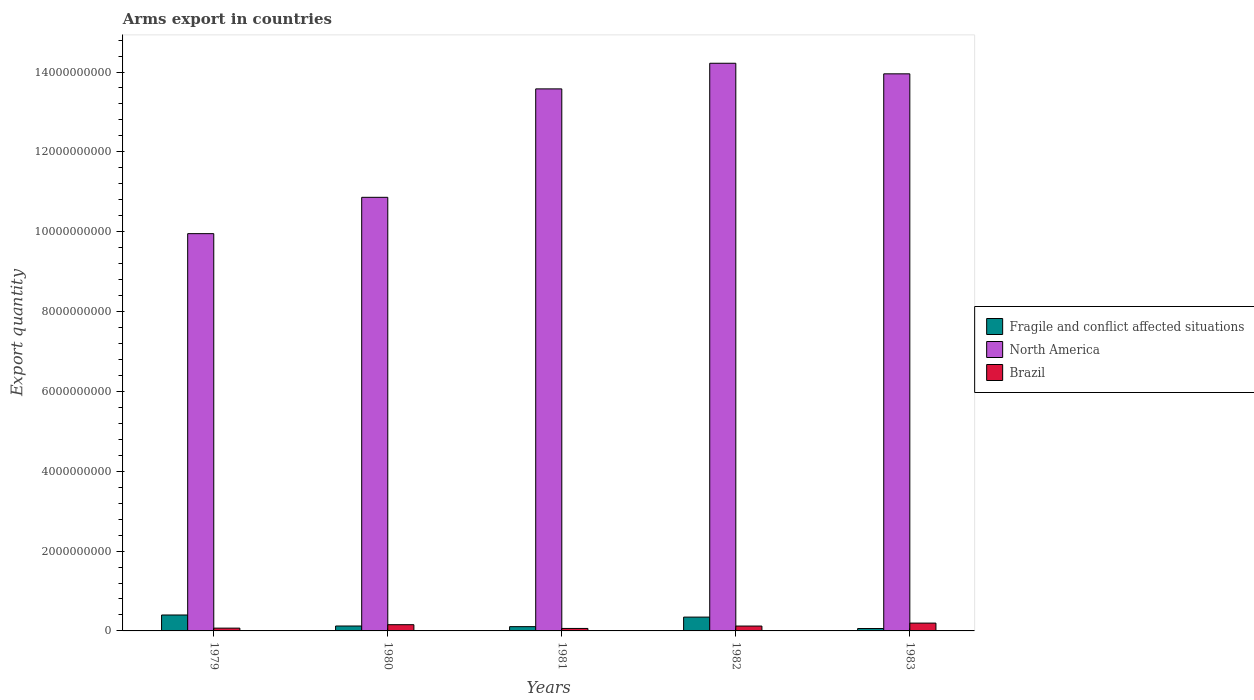How many different coloured bars are there?
Give a very brief answer. 3. How many bars are there on the 2nd tick from the left?
Ensure brevity in your answer.  3. How many bars are there on the 4th tick from the right?
Keep it short and to the point. 3. What is the label of the 4th group of bars from the left?
Keep it short and to the point. 1982. In how many cases, is the number of bars for a given year not equal to the number of legend labels?
Provide a short and direct response. 0. What is the total arms export in Brazil in 1979?
Your answer should be very brief. 7.00e+07. Across all years, what is the maximum total arms export in Brazil?
Offer a terse response. 1.96e+08. Across all years, what is the minimum total arms export in Brazil?
Your answer should be very brief. 6.20e+07. What is the total total arms export in North America in the graph?
Keep it short and to the point. 6.26e+1. What is the difference between the total arms export in North America in 1979 and that in 1982?
Provide a succinct answer. -4.27e+09. What is the difference between the total arms export in North America in 1981 and the total arms export in Fragile and conflict affected situations in 1983?
Ensure brevity in your answer.  1.35e+1. What is the average total arms export in Fragile and conflict affected situations per year?
Provide a succinct answer. 2.07e+08. In the year 1983, what is the difference between the total arms export in North America and total arms export in Brazil?
Offer a terse response. 1.38e+1. What is the ratio of the total arms export in Fragile and conflict affected situations in 1981 to that in 1983?
Your answer should be compact. 1.78. Is the difference between the total arms export in North America in 1980 and 1983 greater than the difference between the total arms export in Brazil in 1980 and 1983?
Provide a succinct answer. No. What is the difference between the highest and the second highest total arms export in Brazil?
Ensure brevity in your answer.  4.00e+07. What is the difference between the highest and the lowest total arms export in Fragile and conflict affected situations?
Provide a short and direct response. 3.39e+08. In how many years, is the total arms export in North America greater than the average total arms export in North America taken over all years?
Keep it short and to the point. 3. What does the 1st bar from the right in 1979 represents?
Your response must be concise. Brazil. Is it the case that in every year, the sum of the total arms export in North America and total arms export in Brazil is greater than the total arms export in Fragile and conflict affected situations?
Give a very brief answer. Yes. What is the difference between two consecutive major ticks on the Y-axis?
Give a very brief answer. 2.00e+09. Does the graph contain grids?
Give a very brief answer. No. Where does the legend appear in the graph?
Provide a short and direct response. Center right. How are the legend labels stacked?
Offer a very short reply. Vertical. What is the title of the graph?
Offer a very short reply. Arms export in countries. What is the label or title of the Y-axis?
Provide a succinct answer. Export quantity. What is the Export quantity of Fragile and conflict affected situations in 1979?
Ensure brevity in your answer.  3.99e+08. What is the Export quantity in North America in 1979?
Provide a short and direct response. 9.95e+09. What is the Export quantity in Brazil in 1979?
Your response must be concise. 7.00e+07. What is the Export quantity of Fragile and conflict affected situations in 1980?
Your answer should be compact. 1.23e+08. What is the Export quantity of North America in 1980?
Your response must be concise. 1.09e+1. What is the Export quantity in Brazil in 1980?
Your answer should be very brief. 1.56e+08. What is the Export quantity of Fragile and conflict affected situations in 1981?
Offer a terse response. 1.07e+08. What is the Export quantity of North America in 1981?
Your response must be concise. 1.36e+1. What is the Export quantity of Brazil in 1981?
Keep it short and to the point. 6.20e+07. What is the Export quantity of Fragile and conflict affected situations in 1982?
Your answer should be compact. 3.46e+08. What is the Export quantity of North America in 1982?
Provide a short and direct response. 1.42e+1. What is the Export quantity of Brazil in 1982?
Provide a short and direct response. 1.22e+08. What is the Export quantity in Fragile and conflict affected situations in 1983?
Provide a short and direct response. 6.00e+07. What is the Export quantity in North America in 1983?
Offer a very short reply. 1.40e+1. What is the Export quantity in Brazil in 1983?
Provide a succinct answer. 1.96e+08. Across all years, what is the maximum Export quantity in Fragile and conflict affected situations?
Provide a succinct answer. 3.99e+08. Across all years, what is the maximum Export quantity of North America?
Provide a short and direct response. 1.42e+1. Across all years, what is the maximum Export quantity of Brazil?
Your answer should be compact. 1.96e+08. Across all years, what is the minimum Export quantity of Fragile and conflict affected situations?
Keep it short and to the point. 6.00e+07. Across all years, what is the minimum Export quantity in North America?
Offer a terse response. 9.95e+09. Across all years, what is the minimum Export quantity in Brazil?
Provide a short and direct response. 6.20e+07. What is the total Export quantity in Fragile and conflict affected situations in the graph?
Provide a succinct answer. 1.04e+09. What is the total Export quantity of North America in the graph?
Keep it short and to the point. 6.26e+1. What is the total Export quantity in Brazil in the graph?
Give a very brief answer. 6.06e+08. What is the difference between the Export quantity in Fragile and conflict affected situations in 1979 and that in 1980?
Your response must be concise. 2.76e+08. What is the difference between the Export quantity of North America in 1979 and that in 1980?
Give a very brief answer. -9.10e+08. What is the difference between the Export quantity of Brazil in 1979 and that in 1980?
Offer a very short reply. -8.60e+07. What is the difference between the Export quantity of Fragile and conflict affected situations in 1979 and that in 1981?
Give a very brief answer. 2.92e+08. What is the difference between the Export quantity of North America in 1979 and that in 1981?
Offer a terse response. -3.63e+09. What is the difference between the Export quantity in Fragile and conflict affected situations in 1979 and that in 1982?
Offer a very short reply. 5.30e+07. What is the difference between the Export quantity of North America in 1979 and that in 1982?
Provide a succinct answer. -4.27e+09. What is the difference between the Export quantity of Brazil in 1979 and that in 1982?
Ensure brevity in your answer.  -5.20e+07. What is the difference between the Export quantity of Fragile and conflict affected situations in 1979 and that in 1983?
Your answer should be very brief. 3.39e+08. What is the difference between the Export quantity in North America in 1979 and that in 1983?
Offer a terse response. -4.00e+09. What is the difference between the Export quantity in Brazil in 1979 and that in 1983?
Offer a very short reply. -1.26e+08. What is the difference between the Export quantity in Fragile and conflict affected situations in 1980 and that in 1981?
Offer a very short reply. 1.60e+07. What is the difference between the Export quantity in North America in 1980 and that in 1981?
Provide a short and direct response. -2.72e+09. What is the difference between the Export quantity in Brazil in 1980 and that in 1981?
Your answer should be very brief. 9.40e+07. What is the difference between the Export quantity of Fragile and conflict affected situations in 1980 and that in 1982?
Ensure brevity in your answer.  -2.23e+08. What is the difference between the Export quantity in North America in 1980 and that in 1982?
Give a very brief answer. -3.36e+09. What is the difference between the Export quantity of Brazil in 1980 and that in 1982?
Offer a terse response. 3.40e+07. What is the difference between the Export quantity in Fragile and conflict affected situations in 1980 and that in 1983?
Offer a very short reply. 6.30e+07. What is the difference between the Export quantity of North America in 1980 and that in 1983?
Make the answer very short. -3.09e+09. What is the difference between the Export quantity of Brazil in 1980 and that in 1983?
Provide a succinct answer. -4.00e+07. What is the difference between the Export quantity of Fragile and conflict affected situations in 1981 and that in 1982?
Keep it short and to the point. -2.39e+08. What is the difference between the Export quantity of North America in 1981 and that in 1982?
Keep it short and to the point. -6.42e+08. What is the difference between the Export quantity in Brazil in 1981 and that in 1982?
Offer a terse response. -6.00e+07. What is the difference between the Export quantity of Fragile and conflict affected situations in 1981 and that in 1983?
Ensure brevity in your answer.  4.70e+07. What is the difference between the Export quantity in North America in 1981 and that in 1983?
Your answer should be very brief. -3.77e+08. What is the difference between the Export quantity of Brazil in 1981 and that in 1983?
Your answer should be very brief. -1.34e+08. What is the difference between the Export quantity of Fragile and conflict affected situations in 1982 and that in 1983?
Your answer should be very brief. 2.86e+08. What is the difference between the Export quantity in North America in 1982 and that in 1983?
Ensure brevity in your answer.  2.65e+08. What is the difference between the Export quantity in Brazil in 1982 and that in 1983?
Provide a short and direct response. -7.40e+07. What is the difference between the Export quantity of Fragile and conflict affected situations in 1979 and the Export quantity of North America in 1980?
Offer a terse response. -1.05e+1. What is the difference between the Export quantity of Fragile and conflict affected situations in 1979 and the Export quantity of Brazil in 1980?
Keep it short and to the point. 2.43e+08. What is the difference between the Export quantity of North America in 1979 and the Export quantity of Brazil in 1980?
Give a very brief answer. 9.80e+09. What is the difference between the Export quantity of Fragile and conflict affected situations in 1979 and the Export quantity of North America in 1981?
Your answer should be very brief. -1.32e+1. What is the difference between the Export quantity in Fragile and conflict affected situations in 1979 and the Export quantity in Brazil in 1981?
Keep it short and to the point. 3.37e+08. What is the difference between the Export quantity of North America in 1979 and the Export quantity of Brazil in 1981?
Provide a short and direct response. 9.89e+09. What is the difference between the Export quantity in Fragile and conflict affected situations in 1979 and the Export quantity in North America in 1982?
Offer a terse response. -1.38e+1. What is the difference between the Export quantity in Fragile and conflict affected situations in 1979 and the Export quantity in Brazil in 1982?
Keep it short and to the point. 2.77e+08. What is the difference between the Export quantity of North America in 1979 and the Export quantity of Brazil in 1982?
Ensure brevity in your answer.  9.83e+09. What is the difference between the Export quantity of Fragile and conflict affected situations in 1979 and the Export quantity of North America in 1983?
Your answer should be very brief. -1.36e+1. What is the difference between the Export quantity of Fragile and conflict affected situations in 1979 and the Export quantity of Brazil in 1983?
Your response must be concise. 2.03e+08. What is the difference between the Export quantity in North America in 1979 and the Export quantity in Brazil in 1983?
Make the answer very short. 9.76e+09. What is the difference between the Export quantity of Fragile and conflict affected situations in 1980 and the Export quantity of North America in 1981?
Your answer should be very brief. -1.35e+1. What is the difference between the Export quantity in Fragile and conflict affected situations in 1980 and the Export quantity in Brazil in 1981?
Provide a succinct answer. 6.10e+07. What is the difference between the Export quantity in North America in 1980 and the Export quantity in Brazil in 1981?
Ensure brevity in your answer.  1.08e+1. What is the difference between the Export quantity in Fragile and conflict affected situations in 1980 and the Export quantity in North America in 1982?
Your answer should be compact. -1.41e+1. What is the difference between the Export quantity in Fragile and conflict affected situations in 1980 and the Export quantity in Brazil in 1982?
Your answer should be very brief. 1.00e+06. What is the difference between the Export quantity in North America in 1980 and the Export quantity in Brazil in 1982?
Give a very brief answer. 1.07e+1. What is the difference between the Export quantity in Fragile and conflict affected situations in 1980 and the Export quantity in North America in 1983?
Provide a succinct answer. -1.38e+1. What is the difference between the Export quantity in Fragile and conflict affected situations in 1980 and the Export quantity in Brazil in 1983?
Ensure brevity in your answer.  -7.30e+07. What is the difference between the Export quantity of North America in 1980 and the Export quantity of Brazil in 1983?
Give a very brief answer. 1.07e+1. What is the difference between the Export quantity in Fragile and conflict affected situations in 1981 and the Export quantity in North America in 1982?
Offer a very short reply. -1.41e+1. What is the difference between the Export quantity in Fragile and conflict affected situations in 1981 and the Export quantity in Brazil in 1982?
Give a very brief answer. -1.50e+07. What is the difference between the Export quantity in North America in 1981 and the Export quantity in Brazil in 1982?
Provide a short and direct response. 1.35e+1. What is the difference between the Export quantity in Fragile and conflict affected situations in 1981 and the Export quantity in North America in 1983?
Make the answer very short. -1.38e+1. What is the difference between the Export quantity of Fragile and conflict affected situations in 1981 and the Export quantity of Brazil in 1983?
Your answer should be compact. -8.90e+07. What is the difference between the Export quantity of North America in 1981 and the Export quantity of Brazil in 1983?
Provide a short and direct response. 1.34e+1. What is the difference between the Export quantity of Fragile and conflict affected situations in 1982 and the Export quantity of North America in 1983?
Keep it short and to the point. -1.36e+1. What is the difference between the Export quantity of Fragile and conflict affected situations in 1982 and the Export quantity of Brazil in 1983?
Ensure brevity in your answer.  1.50e+08. What is the difference between the Export quantity of North America in 1982 and the Export quantity of Brazil in 1983?
Make the answer very short. 1.40e+1. What is the average Export quantity in Fragile and conflict affected situations per year?
Offer a terse response. 2.07e+08. What is the average Export quantity in North America per year?
Your answer should be very brief. 1.25e+1. What is the average Export quantity of Brazil per year?
Provide a short and direct response. 1.21e+08. In the year 1979, what is the difference between the Export quantity of Fragile and conflict affected situations and Export quantity of North America?
Keep it short and to the point. -9.55e+09. In the year 1979, what is the difference between the Export quantity of Fragile and conflict affected situations and Export quantity of Brazil?
Provide a short and direct response. 3.29e+08. In the year 1979, what is the difference between the Export quantity of North America and Export quantity of Brazil?
Provide a short and direct response. 9.88e+09. In the year 1980, what is the difference between the Export quantity in Fragile and conflict affected situations and Export quantity in North America?
Provide a short and direct response. -1.07e+1. In the year 1980, what is the difference between the Export quantity of Fragile and conflict affected situations and Export quantity of Brazil?
Give a very brief answer. -3.30e+07. In the year 1980, what is the difference between the Export quantity of North America and Export quantity of Brazil?
Your answer should be very brief. 1.07e+1. In the year 1981, what is the difference between the Export quantity in Fragile and conflict affected situations and Export quantity in North America?
Offer a very short reply. -1.35e+1. In the year 1981, what is the difference between the Export quantity of Fragile and conflict affected situations and Export quantity of Brazil?
Make the answer very short. 4.50e+07. In the year 1981, what is the difference between the Export quantity in North America and Export quantity in Brazil?
Make the answer very short. 1.35e+1. In the year 1982, what is the difference between the Export quantity of Fragile and conflict affected situations and Export quantity of North America?
Keep it short and to the point. -1.39e+1. In the year 1982, what is the difference between the Export quantity of Fragile and conflict affected situations and Export quantity of Brazil?
Offer a terse response. 2.24e+08. In the year 1982, what is the difference between the Export quantity in North America and Export quantity in Brazil?
Your answer should be very brief. 1.41e+1. In the year 1983, what is the difference between the Export quantity of Fragile and conflict affected situations and Export quantity of North America?
Your response must be concise. -1.39e+1. In the year 1983, what is the difference between the Export quantity of Fragile and conflict affected situations and Export quantity of Brazil?
Offer a very short reply. -1.36e+08. In the year 1983, what is the difference between the Export quantity in North America and Export quantity in Brazil?
Make the answer very short. 1.38e+1. What is the ratio of the Export quantity in Fragile and conflict affected situations in 1979 to that in 1980?
Provide a short and direct response. 3.24. What is the ratio of the Export quantity of North America in 1979 to that in 1980?
Provide a short and direct response. 0.92. What is the ratio of the Export quantity in Brazil in 1979 to that in 1980?
Your answer should be very brief. 0.45. What is the ratio of the Export quantity of Fragile and conflict affected situations in 1979 to that in 1981?
Your response must be concise. 3.73. What is the ratio of the Export quantity in North America in 1979 to that in 1981?
Provide a short and direct response. 0.73. What is the ratio of the Export quantity of Brazil in 1979 to that in 1981?
Your answer should be very brief. 1.13. What is the ratio of the Export quantity in Fragile and conflict affected situations in 1979 to that in 1982?
Offer a terse response. 1.15. What is the ratio of the Export quantity in North America in 1979 to that in 1982?
Make the answer very short. 0.7. What is the ratio of the Export quantity of Brazil in 1979 to that in 1982?
Your answer should be very brief. 0.57. What is the ratio of the Export quantity of Fragile and conflict affected situations in 1979 to that in 1983?
Make the answer very short. 6.65. What is the ratio of the Export quantity of North America in 1979 to that in 1983?
Make the answer very short. 0.71. What is the ratio of the Export quantity in Brazil in 1979 to that in 1983?
Your answer should be very brief. 0.36. What is the ratio of the Export quantity of Fragile and conflict affected situations in 1980 to that in 1981?
Keep it short and to the point. 1.15. What is the ratio of the Export quantity in North America in 1980 to that in 1981?
Provide a succinct answer. 0.8. What is the ratio of the Export quantity of Brazil in 1980 to that in 1981?
Offer a very short reply. 2.52. What is the ratio of the Export quantity of Fragile and conflict affected situations in 1980 to that in 1982?
Offer a very short reply. 0.36. What is the ratio of the Export quantity in North America in 1980 to that in 1982?
Give a very brief answer. 0.76. What is the ratio of the Export quantity in Brazil in 1980 to that in 1982?
Your answer should be compact. 1.28. What is the ratio of the Export quantity in Fragile and conflict affected situations in 1980 to that in 1983?
Make the answer very short. 2.05. What is the ratio of the Export quantity of North America in 1980 to that in 1983?
Your answer should be very brief. 0.78. What is the ratio of the Export quantity of Brazil in 1980 to that in 1983?
Your response must be concise. 0.8. What is the ratio of the Export quantity of Fragile and conflict affected situations in 1981 to that in 1982?
Offer a very short reply. 0.31. What is the ratio of the Export quantity in North America in 1981 to that in 1982?
Provide a short and direct response. 0.95. What is the ratio of the Export quantity in Brazil in 1981 to that in 1982?
Your answer should be very brief. 0.51. What is the ratio of the Export quantity in Fragile and conflict affected situations in 1981 to that in 1983?
Provide a succinct answer. 1.78. What is the ratio of the Export quantity in North America in 1981 to that in 1983?
Your response must be concise. 0.97. What is the ratio of the Export quantity in Brazil in 1981 to that in 1983?
Offer a terse response. 0.32. What is the ratio of the Export quantity in Fragile and conflict affected situations in 1982 to that in 1983?
Your answer should be compact. 5.77. What is the ratio of the Export quantity of Brazil in 1982 to that in 1983?
Offer a terse response. 0.62. What is the difference between the highest and the second highest Export quantity of Fragile and conflict affected situations?
Give a very brief answer. 5.30e+07. What is the difference between the highest and the second highest Export quantity in North America?
Keep it short and to the point. 2.65e+08. What is the difference between the highest and the second highest Export quantity of Brazil?
Give a very brief answer. 4.00e+07. What is the difference between the highest and the lowest Export quantity of Fragile and conflict affected situations?
Provide a short and direct response. 3.39e+08. What is the difference between the highest and the lowest Export quantity in North America?
Offer a very short reply. 4.27e+09. What is the difference between the highest and the lowest Export quantity in Brazil?
Keep it short and to the point. 1.34e+08. 